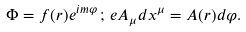<formula> <loc_0><loc_0><loc_500><loc_500>\Phi = f ( r ) e ^ { i m \varphi } \, ; \, e A _ { \mu } d x ^ { \mu } = A ( r ) d \varphi .</formula> 